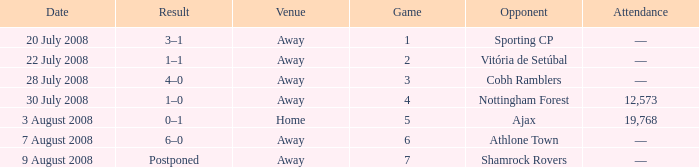What is the total game number with athlone town as the opponent? 1.0. 